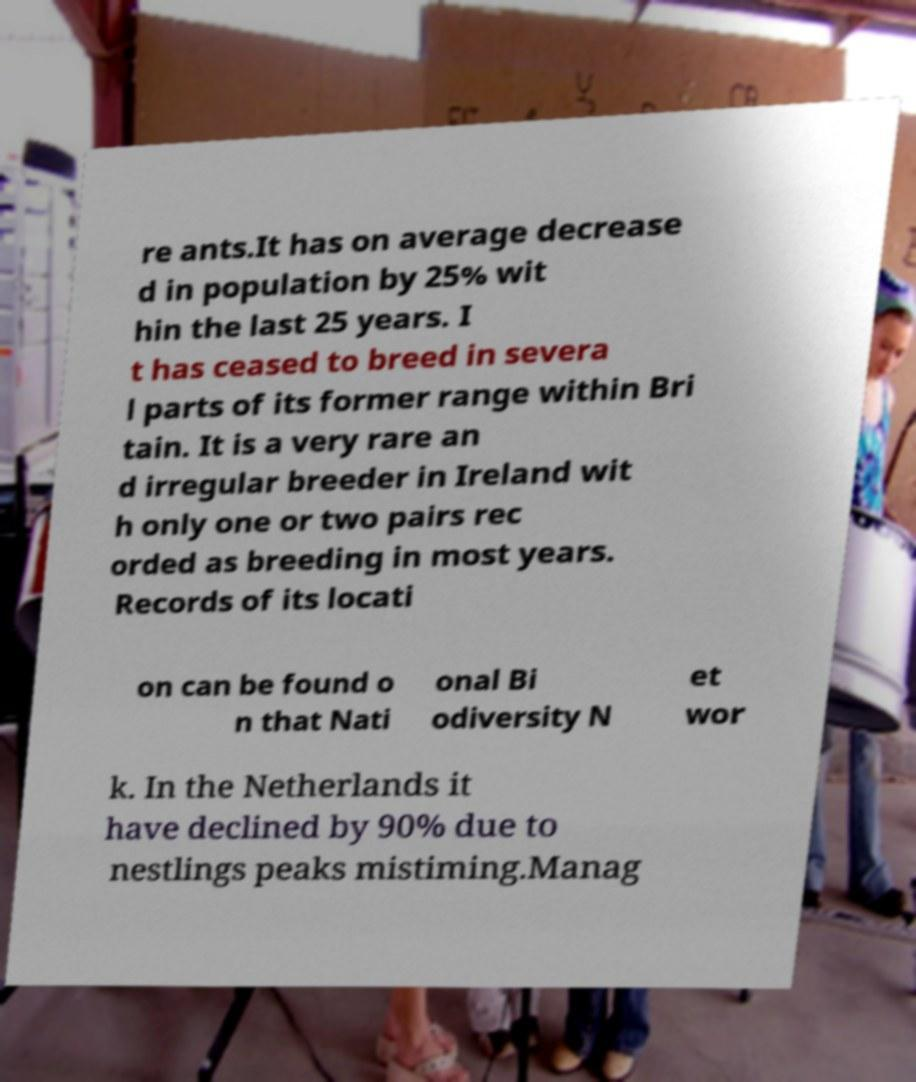For documentation purposes, I need the text within this image transcribed. Could you provide that? re ants.It has on average decrease d in population by 25% wit hin the last 25 years. I t has ceased to breed in severa l parts of its former range within Bri tain. It is a very rare an d irregular breeder in Ireland wit h only one or two pairs rec orded as breeding in most years. Records of its locati on can be found o n that Nati onal Bi odiversity N et wor k. In the Netherlands it have declined by 90% due to nestlings peaks mistiming.Manag 